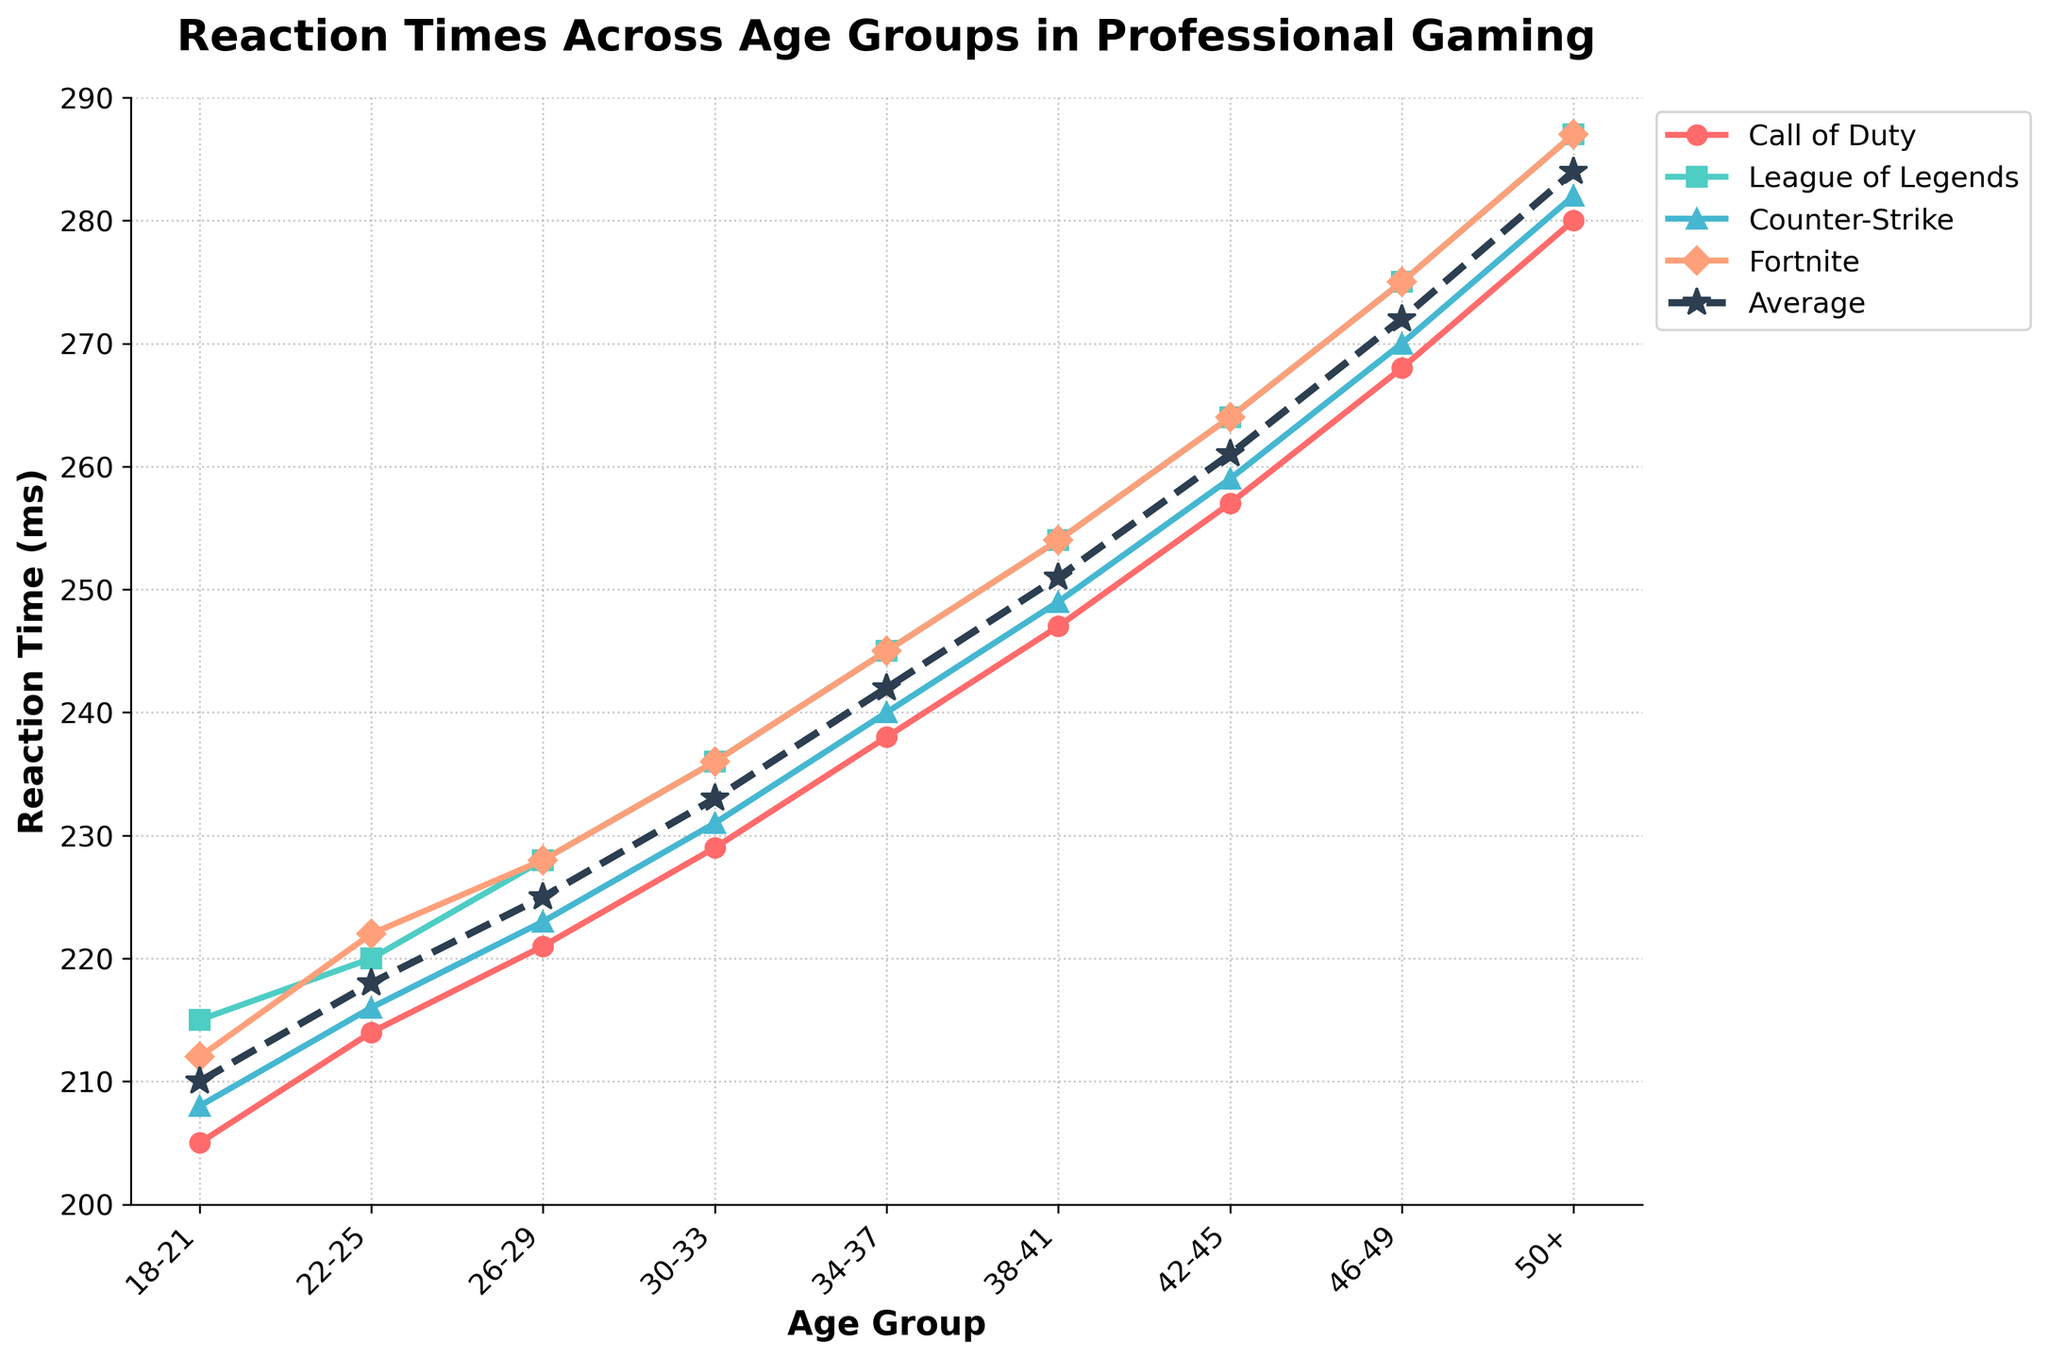What's the difference in reaction time between the 18-21 age group and the 50+ age group? The reaction time for the 18-21 age group is 210 ms, while for the 50+ age group it's 284 ms. So, the difference is 284 - 210 = 74 ms
Answer: 74 ms Which game has the highest reaction time for the 30-33 age group? For the 30-33 age group, the reaction times are 229 ms for Call of Duty, 236 ms for League of Legends, 231 ms for Counter-Strike, and 236 ms for Fortnite. League of Legends and Fortnite have the highest equal reaction times at 236 ms
Answer: League of Legends and Fortnite How does the average reaction time change from the 22-25 age group to the 26-29 age group? The average reaction time in the 22-25 age group is 218 ms, and in the 26-29 age group, it is 225 ms. The change is 225 - 218 = 7 ms
Answer: Increases by 7 ms Which age group has the lowest reaction time for Call of Duty? By observing the plot, the 18-21 age group has the lowest reaction time for Call of Duty at 205 ms
Answer: 18-21 Is the reaction time for Fortnite in the 46-49 age group greater than the average reaction time for the same age group? The reaction time for Fortnite in the 46-49 age group is 275 ms, while the average reaction time for the same age group is 272 ms. Since 275 ms > 272 ms, the reaction time for Fortnite is greater
Answer: Yes By how much does the reaction time of Counter-Strike exceed the average for the 34-37 age group? The reaction time for Counter-Strike in the 34-37 age group is 240 ms, while the average reaction time for the same age group is 242 ms. The difference is 240 ms - 242 ms = -2 ms, meaning it's actually 2 ms less
Answer: 2 ms less At which age group do all four games first show reaction times above 230 ms? By scanning the plot, the 30-33 age group is the first for which all games have reaction times above 230 ms. In this group, Call of Duty has 229 ms, League of Legends has 236 ms, Counter-Strike has 231 ms, and Fortnite has 236 ms. Since between 34-37, all games are above 230 ms. The correct answer is 34 – 37
Answer: 34-37 